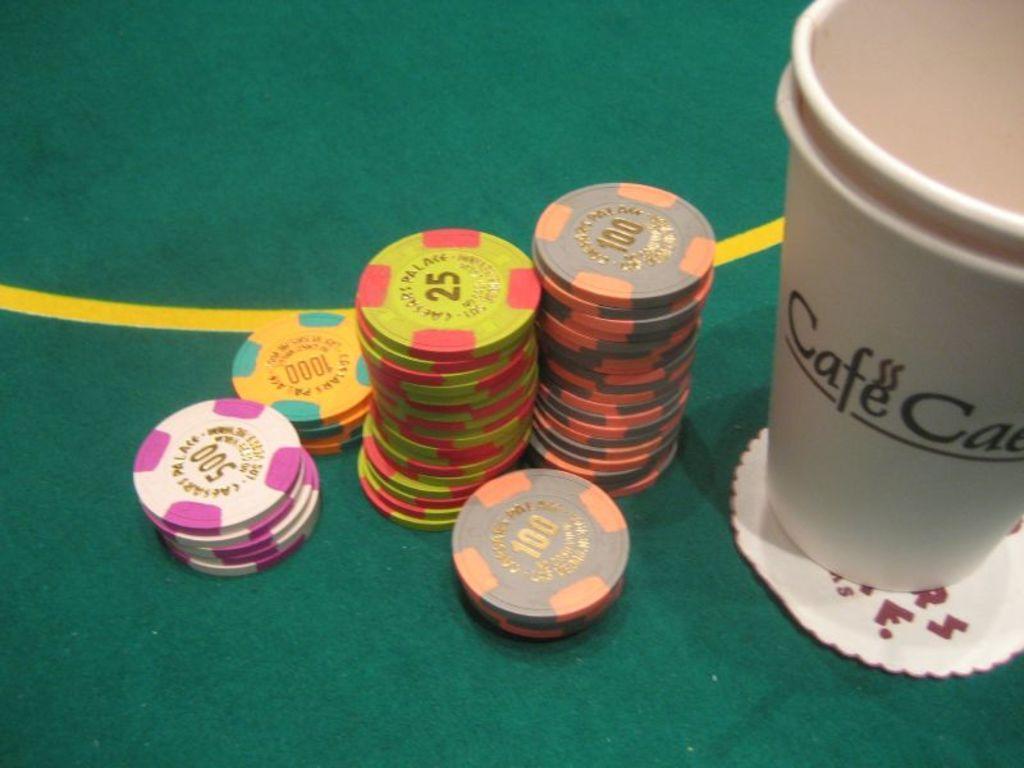Can you describe this image briefly? W can see many coins with different colors and different numbers on it. There is a 500 number on the pink color coin. We can see 100 number on the orange color coin. And a 25 number on the green color coin. And a 1000 number coin on orange color coin. There is a green table. To right side there is a cup with cafe on it. And under the cup there is a small paper. 